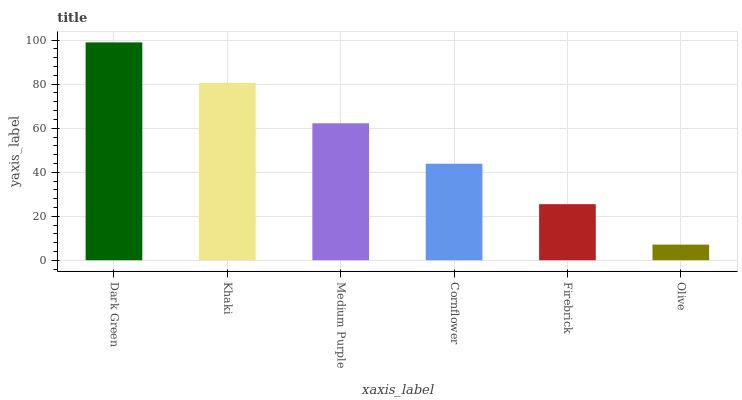Is Khaki the minimum?
Answer yes or no. No. Is Khaki the maximum?
Answer yes or no. No. Is Dark Green greater than Khaki?
Answer yes or no. Yes. Is Khaki less than Dark Green?
Answer yes or no. Yes. Is Khaki greater than Dark Green?
Answer yes or no. No. Is Dark Green less than Khaki?
Answer yes or no. No. Is Medium Purple the high median?
Answer yes or no. Yes. Is Cornflower the low median?
Answer yes or no. Yes. Is Khaki the high median?
Answer yes or no. No. Is Dark Green the low median?
Answer yes or no. No. 